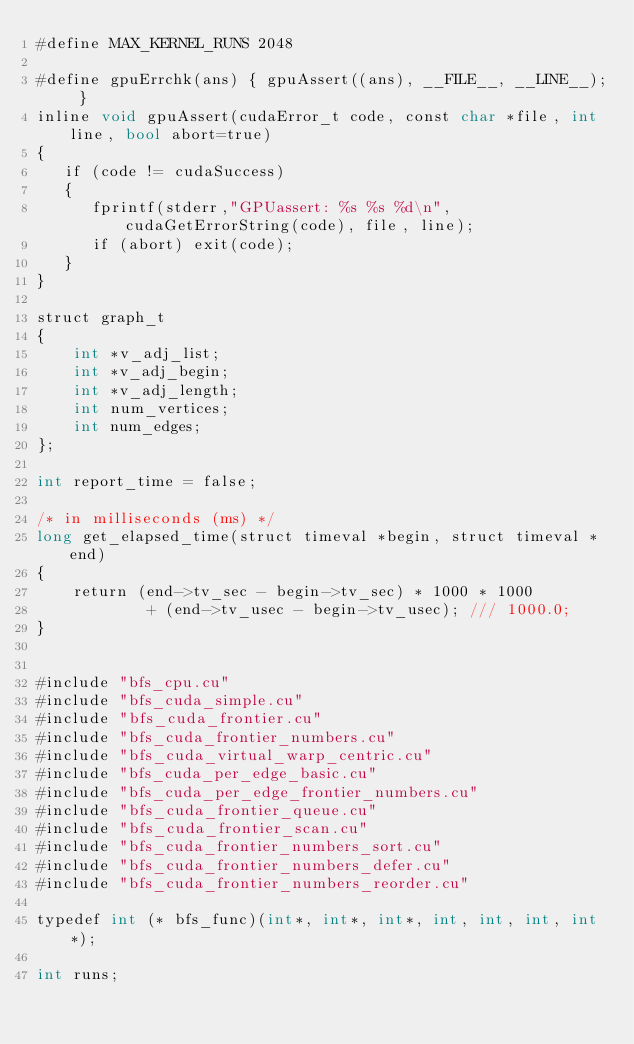<code> <loc_0><loc_0><loc_500><loc_500><_Cuda_>#define MAX_KERNEL_RUNS 2048

#define gpuErrchk(ans) { gpuAssert((ans), __FILE__, __LINE__); }
inline void gpuAssert(cudaError_t code, const char *file, int line, bool abort=true)
{
   if (code != cudaSuccess) 
   {
      fprintf(stderr,"GPUassert: %s %s %d\n", cudaGetErrorString(code), file, line);
      if (abort) exit(code);
   }
}

struct graph_t
{
    int *v_adj_list;
    int *v_adj_begin;
    int *v_adj_length;  
    int num_vertices;    
    int num_edges;
};

int report_time = false;

/* in milliseconds (ms) */
long get_elapsed_time(struct timeval *begin, struct timeval *end)
{
    return (end->tv_sec - begin->tv_sec) * 1000 * 1000
            + (end->tv_usec - begin->tv_usec); /// 1000.0;
}


#include "bfs_cpu.cu"
#include "bfs_cuda_simple.cu"
#include "bfs_cuda_frontier.cu"
#include "bfs_cuda_frontier_numbers.cu"
#include "bfs_cuda_virtual_warp_centric.cu"
#include "bfs_cuda_per_edge_basic.cu"
#include "bfs_cuda_per_edge_frontier_numbers.cu"
#include "bfs_cuda_frontier_queue.cu"
#include "bfs_cuda_frontier_scan.cu"
#include "bfs_cuda_frontier_numbers_sort.cu"
#include "bfs_cuda_frontier_numbers_defer.cu"
#include "bfs_cuda_frontier_numbers_reorder.cu"

typedef int (* bfs_func)(int*, int*, int*, int, int, int, int*);

int runs;</code> 